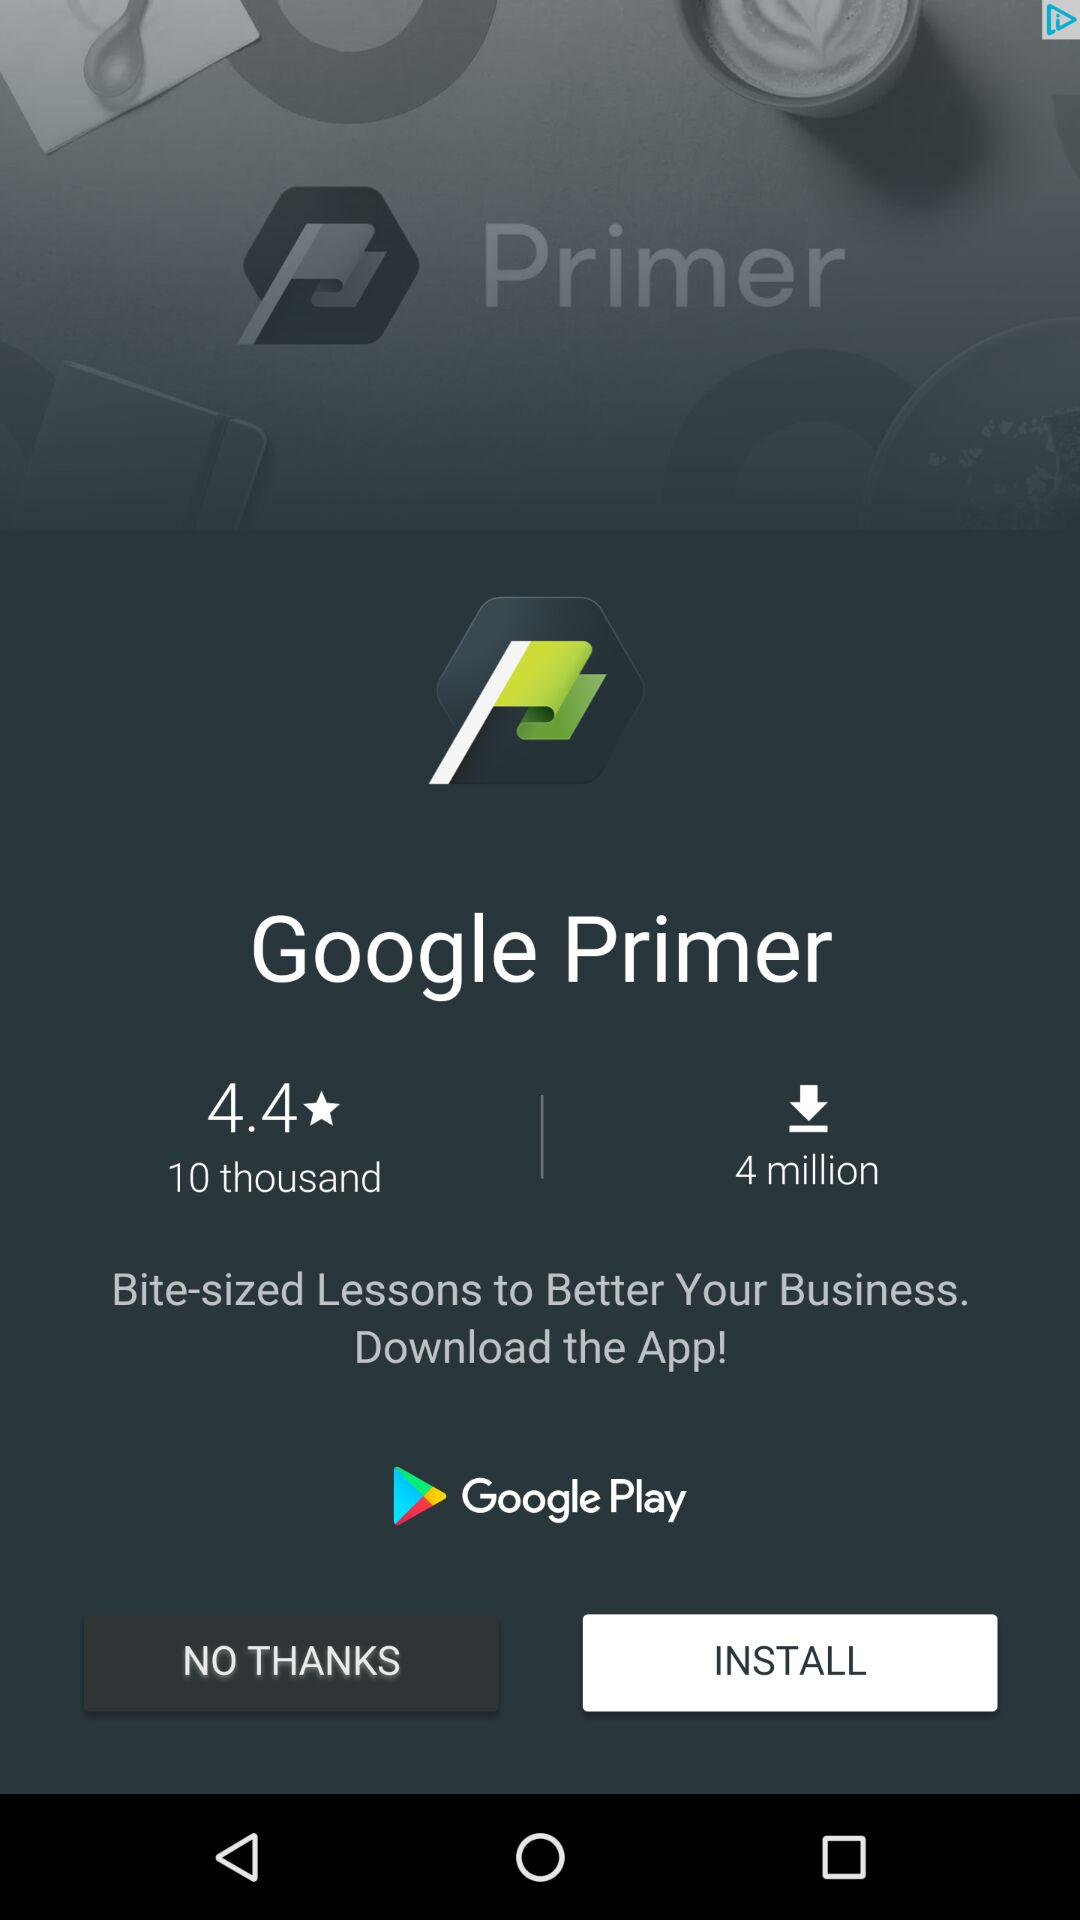How many downloads does the app have?
Answer the question using a single word or phrase. 4 million 